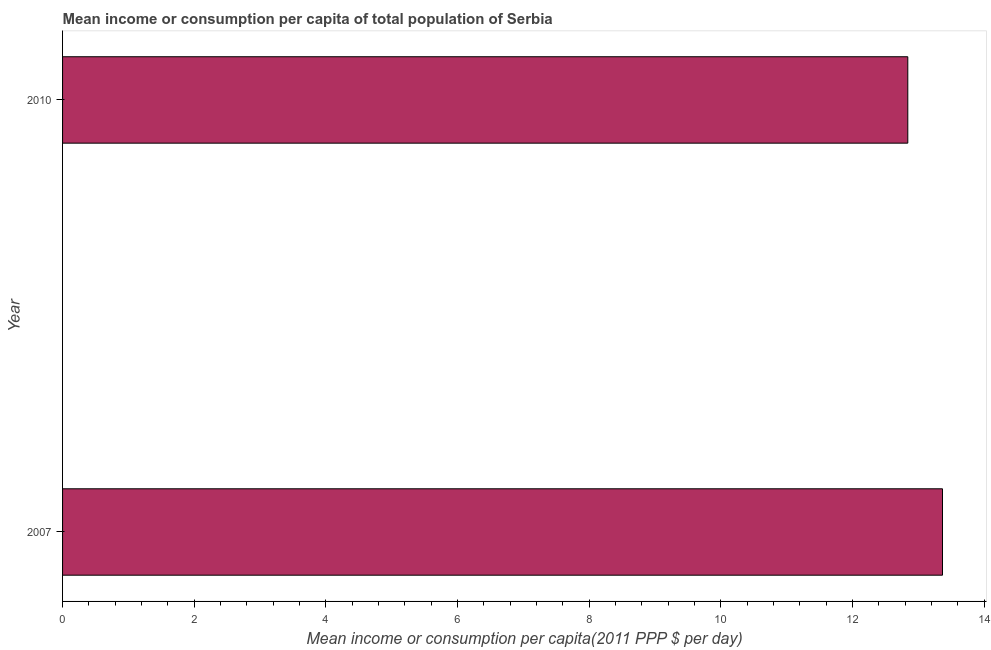Does the graph contain grids?
Your answer should be very brief. No. What is the title of the graph?
Your response must be concise. Mean income or consumption per capita of total population of Serbia. What is the label or title of the X-axis?
Your response must be concise. Mean income or consumption per capita(2011 PPP $ per day). What is the label or title of the Y-axis?
Give a very brief answer. Year. What is the mean income or consumption in 2007?
Offer a terse response. 13.37. Across all years, what is the maximum mean income or consumption?
Give a very brief answer. 13.37. Across all years, what is the minimum mean income or consumption?
Provide a succinct answer. 12.84. In which year was the mean income or consumption minimum?
Your response must be concise. 2010. What is the sum of the mean income or consumption?
Offer a very short reply. 26.21. What is the difference between the mean income or consumption in 2007 and 2010?
Offer a terse response. 0.53. What is the average mean income or consumption per year?
Offer a terse response. 13.11. What is the median mean income or consumption?
Make the answer very short. 13.1. In how many years, is the mean income or consumption greater than 10.4 $?
Your answer should be very brief. 2. Do a majority of the years between 2007 and 2010 (inclusive) have mean income or consumption greater than 0.4 $?
Your response must be concise. Yes. What is the ratio of the mean income or consumption in 2007 to that in 2010?
Provide a short and direct response. 1.04. Is the mean income or consumption in 2007 less than that in 2010?
Keep it short and to the point. No. How many bars are there?
Your answer should be compact. 2. Are all the bars in the graph horizontal?
Ensure brevity in your answer.  Yes. Are the values on the major ticks of X-axis written in scientific E-notation?
Make the answer very short. No. What is the Mean income or consumption per capita(2011 PPP $ per day) in 2007?
Make the answer very short. 13.37. What is the Mean income or consumption per capita(2011 PPP $ per day) in 2010?
Provide a short and direct response. 12.84. What is the difference between the Mean income or consumption per capita(2011 PPP $ per day) in 2007 and 2010?
Keep it short and to the point. 0.53. What is the ratio of the Mean income or consumption per capita(2011 PPP $ per day) in 2007 to that in 2010?
Give a very brief answer. 1.04. 